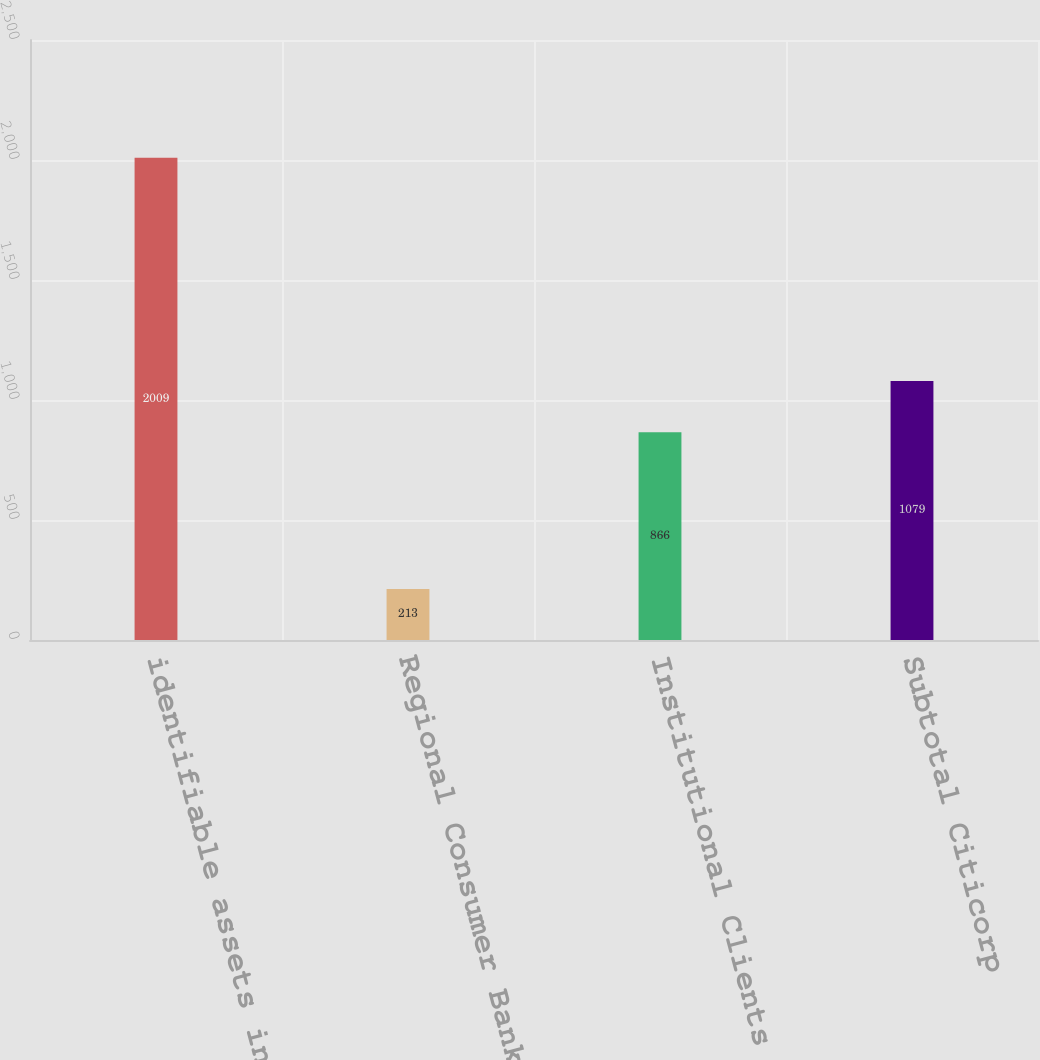Convert chart. <chart><loc_0><loc_0><loc_500><loc_500><bar_chart><fcel>identifiable assets in<fcel>Regional Consumer Banking<fcel>Institutional Clients Group<fcel>Subtotal Citicorp<nl><fcel>2009<fcel>213<fcel>866<fcel>1079<nl></chart> 